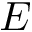Convert formula to latex. <formula><loc_0><loc_0><loc_500><loc_500>E</formula> 